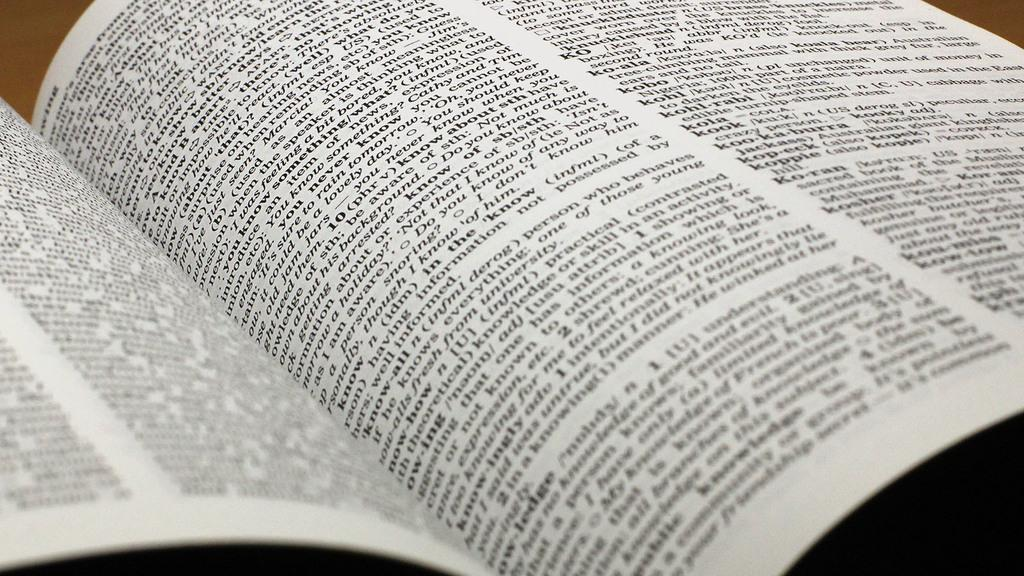<image>
Present a compact description of the photo's key features. A dictionary is left open on a table. 